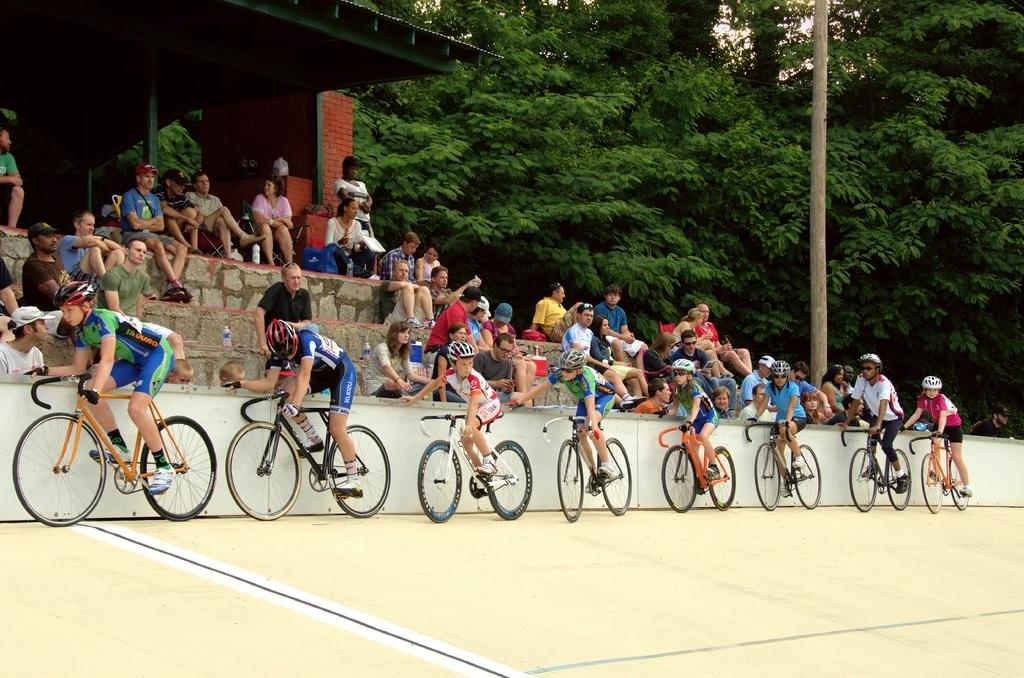What are the people doing in the image? The people are on bicycles in the image. What can be seen in the background of the image? There are people sitting and trees in the background of the image. Can you tell me how many owls are perched on the bicycles in the image? There are no owls present in the image; it features people on bicycles and people sitting in the background. 